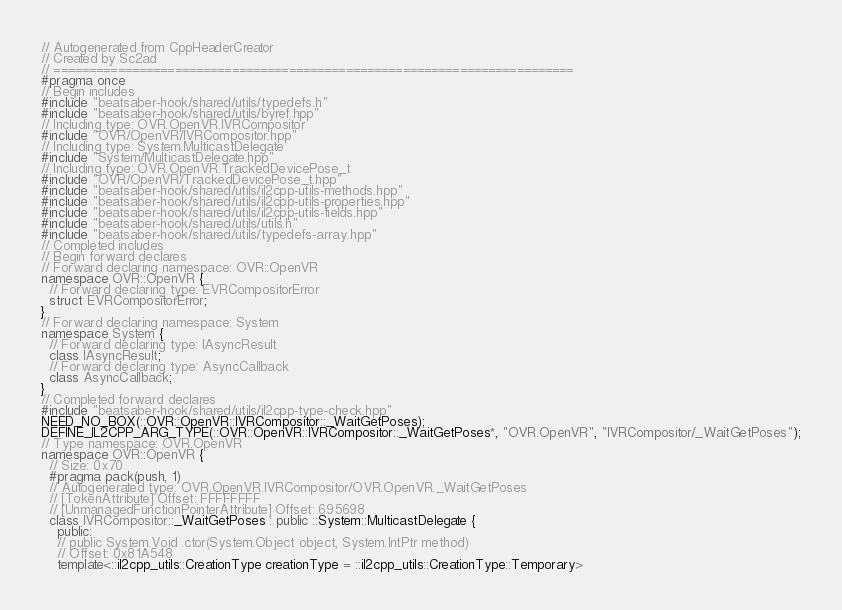<code> <loc_0><loc_0><loc_500><loc_500><_C++_>// Autogenerated from CppHeaderCreator
// Created by Sc2ad
// =========================================================================
#pragma once
// Begin includes
#include "beatsaber-hook/shared/utils/typedefs.h"
#include "beatsaber-hook/shared/utils/byref.hpp"
// Including type: OVR.OpenVR.IVRCompositor
#include "OVR/OpenVR/IVRCompositor.hpp"
// Including type: System.MulticastDelegate
#include "System/MulticastDelegate.hpp"
// Including type: OVR.OpenVR.TrackedDevicePose_t
#include "OVR/OpenVR/TrackedDevicePose_t.hpp"
#include "beatsaber-hook/shared/utils/il2cpp-utils-methods.hpp"
#include "beatsaber-hook/shared/utils/il2cpp-utils-properties.hpp"
#include "beatsaber-hook/shared/utils/il2cpp-utils-fields.hpp"
#include "beatsaber-hook/shared/utils/utils.h"
#include "beatsaber-hook/shared/utils/typedefs-array.hpp"
// Completed includes
// Begin forward declares
// Forward declaring namespace: OVR::OpenVR
namespace OVR::OpenVR {
  // Forward declaring type: EVRCompositorError
  struct EVRCompositorError;
}
// Forward declaring namespace: System
namespace System {
  // Forward declaring type: IAsyncResult
  class IAsyncResult;
  // Forward declaring type: AsyncCallback
  class AsyncCallback;
}
// Completed forward declares
#include "beatsaber-hook/shared/utils/il2cpp-type-check.hpp"
NEED_NO_BOX(::OVR::OpenVR::IVRCompositor::_WaitGetPoses);
DEFINE_IL2CPP_ARG_TYPE(::OVR::OpenVR::IVRCompositor::_WaitGetPoses*, "OVR.OpenVR", "IVRCompositor/_WaitGetPoses");
// Type namespace: OVR.OpenVR
namespace OVR::OpenVR {
  // Size: 0x70
  #pragma pack(push, 1)
  // Autogenerated type: OVR.OpenVR.IVRCompositor/OVR.OpenVR._WaitGetPoses
  // [TokenAttribute] Offset: FFFFFFFF
  // [UnmanagedFunctionPointerAttribute] Offset: 695698
  class IVRCompositor::_WaitGetPoses : public ::System::MulticastDelegate {
    public:
    // public System.Void .ctor(System.Object object, System.IntPtr method)
    // Offset: 0x81A548
    template<::il2cpp_utils::CreationType creationType = ::il2cpp_utils::CreationType::Temporary></code> 